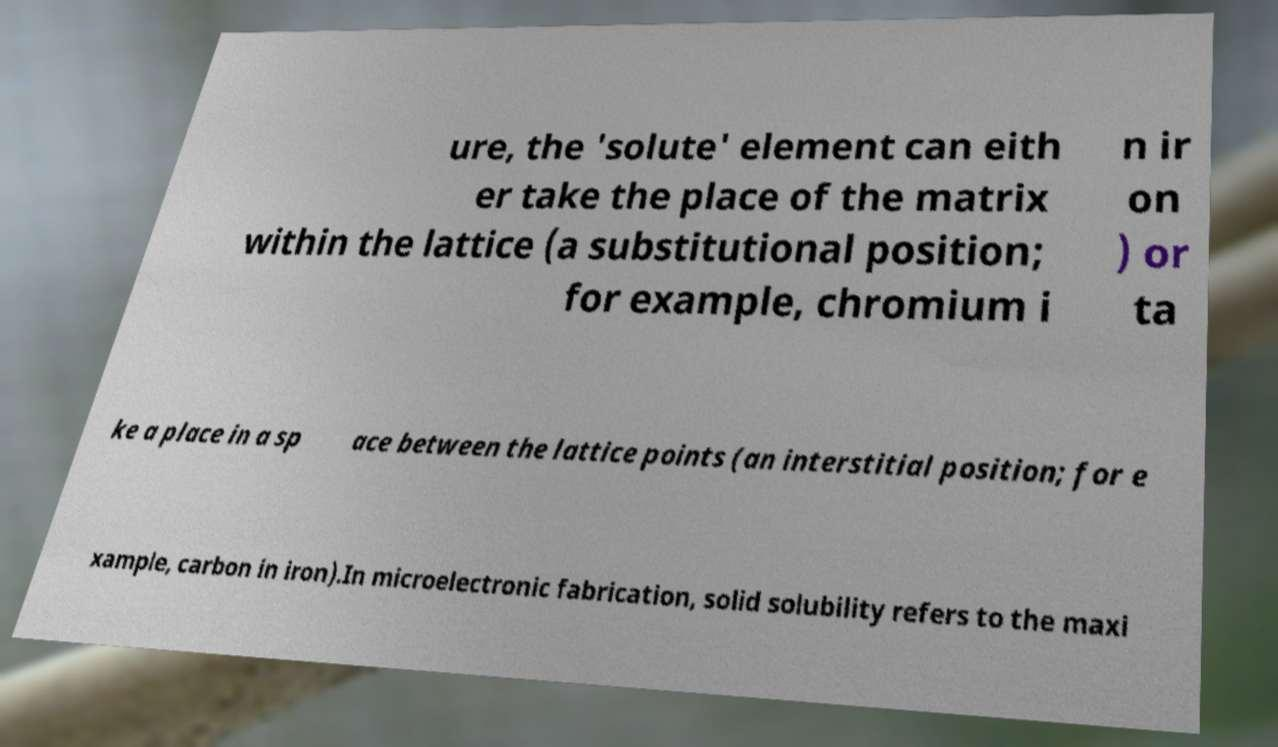There's text embedded in this image that I need extracted. Can you transcribe it verbatim? ure, the 'solute' element can eith er take the place of the matrix within the lattice (a substitutional position; for example, chromium i n ir on ) or ta ke a place in a sp ace between the lattice points (an interstitial position; for e xample, carbon in iron).In microelectronic fabrication, solid solubility refers to the maxi 